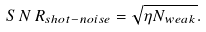Convert formula to latex. <formula><loc_0><loc_0><loc_500><loc_500>S \, N \, R _ { s h o t - n o i s e } = \sqrt { \eta N _ { w e a k } } .</formula> 